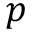Convert formula to latex. <formula><loc_0><loc_0><loc_500><loc_500>p</formula> 